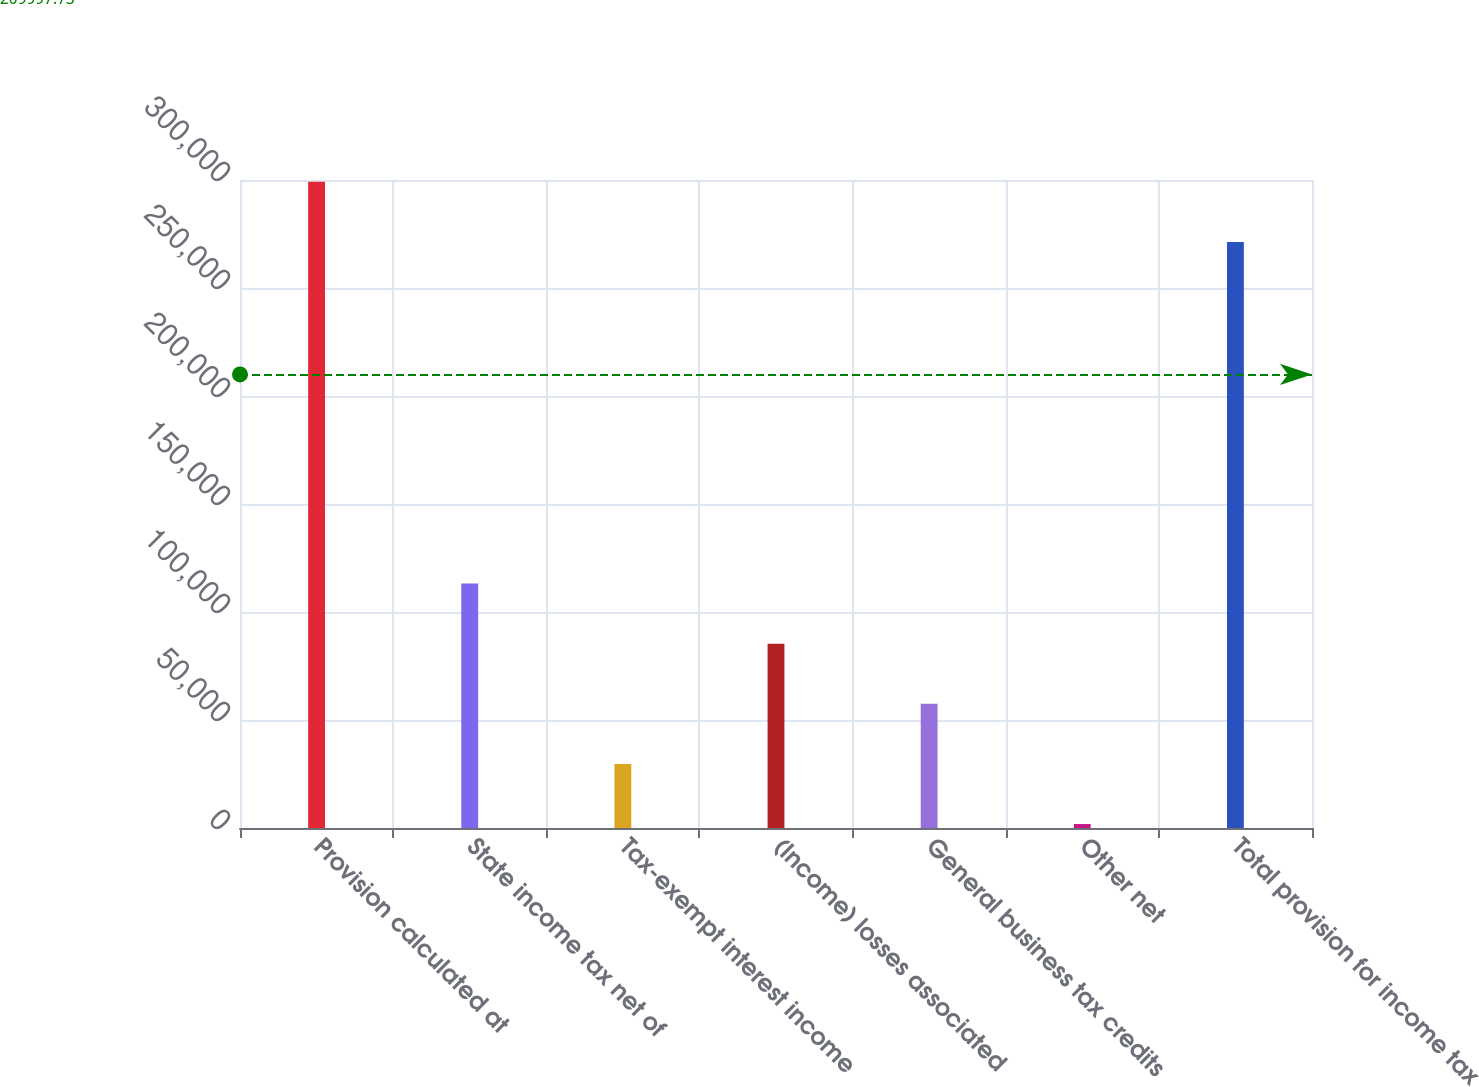Convert chart to OTSL. <chart><loc_0><loc_0><loc_500><loc_500><bar_chart><fcel>Provision calculated at<fcel>State income tax net of<fcel>Tax-exempt interest income<fcel>(Income) losses associated<fcel>General business tax credits<fcel>Other net<fcel>Total provision for income tax<nl><fcel>299132<fcel>113188<fcel>29669.5<fcel>85348.5<fcel>57509<fcel>1830<fcel>271293<nl></chart> 